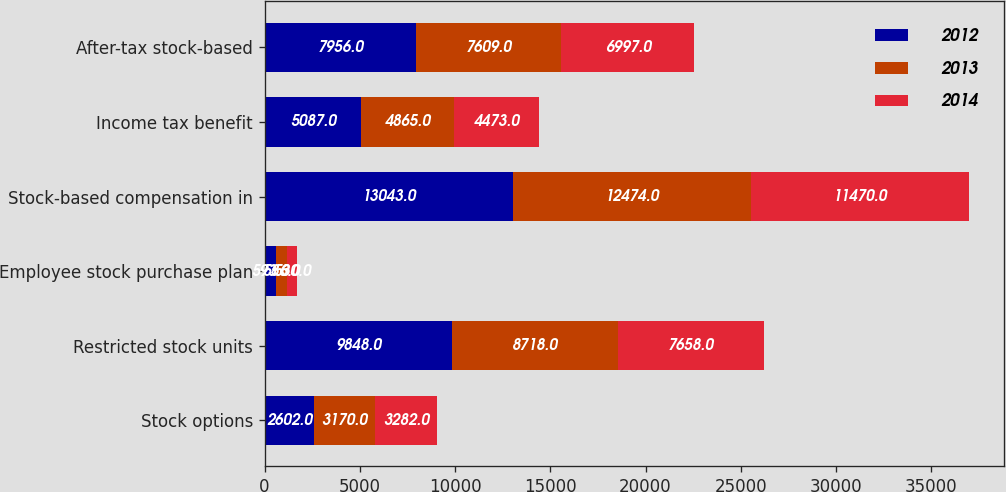Convert chart. <chart><loc_0><loc_0><loc_500><loc_500><stacked_bar_chart><ecel><fcel>Stock options<fcel>Restricted stock units<fcel>Employee stock purchase plan<fcel>Stock-based compensation in<fcel>Income tax benefit<fcel>After-tax stock-based<nl><fcel>2012<fcel>2602<fcel>9848<fcel>593<fcel>13043<fcel>5087<fcel>7956<nl><fcel>2013<fcel>3170<fcel>8718<fcel>586<fcel>12474<fcel>4865<fcel>7609<nl><fcel>2014<fcel>3282<fcel>7658<fcel>530<fcel>11470<fcel>4473<fcel>6997<nl></chart> 